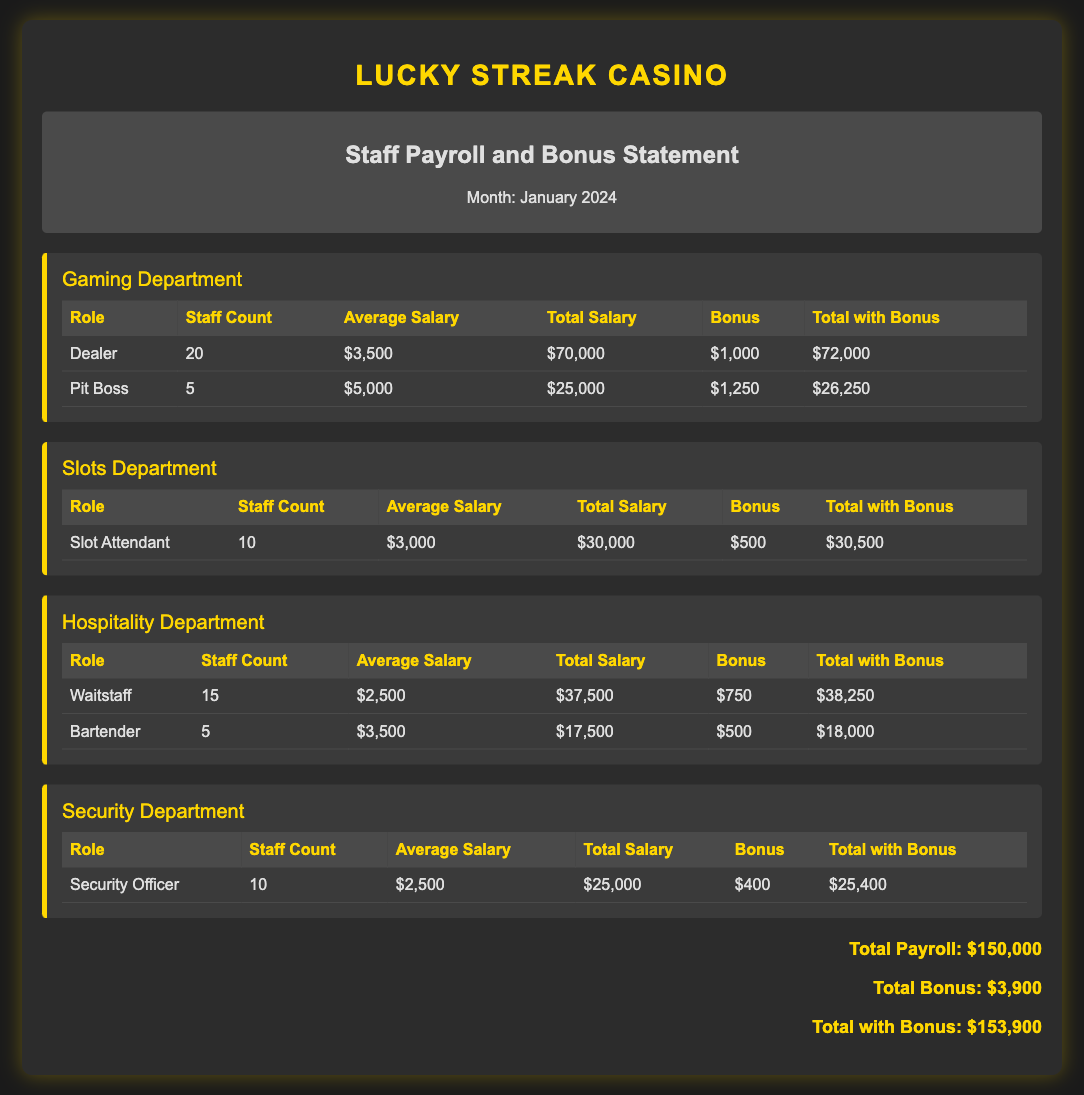what is the total salary for Dealers? The total salary for Dealers is listed in the Gaming Department section, which is $70,000.
Answer: $70,000 how many Bartenders are there? The count of Bartenders can be found in the Hospitality Department section, where it states there are 5 Bartenders.
Answer: 5 what is the bonus for Security Officers? The bonus for Security Officers is provided in the Security Department section, which is $400.
Answer: $400 what is the total payroll for the month of January 2024? The total payroll for January 2024 is summarized at the bottom of the document, which is $150,000.
Answer: $150,000 which department has the highest average salary for its roles? To determine which department has the highest average salary, we compare the average salaries across departments, specifically noting that the Pit Boss has the highest average salary at $5,000 in the Gaming Department.
Answer: Gaming Department what is the total with bonus for Slot Attendants? The total with bonus for Slot Attendants is listed next to their segment, which is $30,500.
Answer: $30,500 how much bonus is allocated to Waitstaff? The bonus allocated to Waitstaff in the Hospitality Department is stated as $750.
Answer: $750 how many staff members are in the Hospitality Department in total? The total staff in the Hospitality Department can be calculated by adding the counts of Waitstaff and Bartenders, which is 15 + 5 = 20.
Answer: 20 